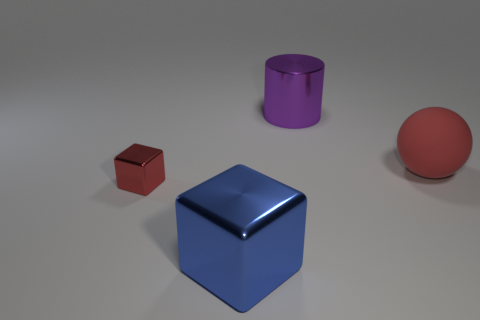What number of green things are the same size as the blue thing?
Make the answer very short. 0. What is the shape of the metal thing that is behind the tiny red shiny block to the left of the big rubber object?
Offer a very short reply. Cylinder. Are there fewer tiny purple metallic spheres than big purple metal cylinders?
Your answer should be compact. Yes. There is a shiny cube that is behind the blue thing; what is its color?
Keep it short and to the point. Red. What material is the object that is both in front of the big ball and to the right of the tiny thing?
Your answer should be compact. Metal. What shape is the tiny object that is made of the same material as the large blue thing?
Make the answer very short. Cube. What number of big purple shiny cylinders are in front of the large metal thing that is behind the big sphere?
Make the answer very short. 0. How many things are on the right side of the large purple shiny cylinder and in front of the small red thing?
Give a very brief answer. 0. How many other objects are the same material as the blue cube?
Ensure brevity in your answer.  2. What is the color of the metallic cube that is on the right side of the cube to the left of the large blue metal cube?
Ensure brevity in your answer.  Blue. 